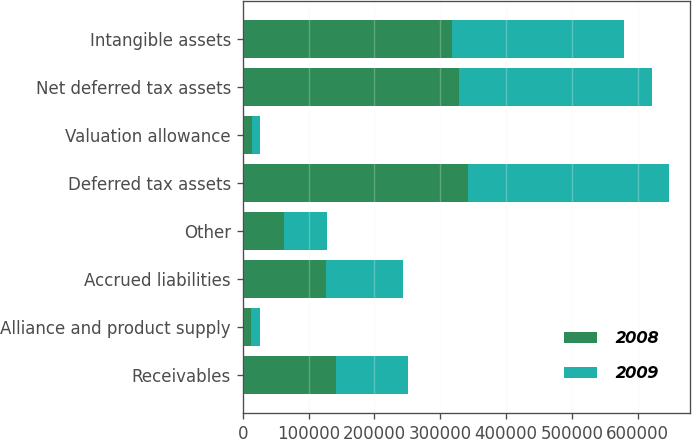<chart> <loc_0><loc_0><loc_500><loc_500><stacked_bar_chart><ecel><fcel>Receivables<fcel>Alliance and product supply<fcel>Accrued liabilities<fcel>Other<fcel>Deferred tax assets<fcel>Valuation allowance<fcel>Net deferred tax assets<fcel>Intangible assets<nl><fcel>2008<fcel>142315<fcel>11922<fcel>125992<fcel>62208<fcel>342437<fcel>14191<fcel>328246<fcel>317306<nl><fcel>2009<fcel>108275<fcel>13995<fcel>117474<fcel>65635<fcel>305379<fcel>12588<fcel>292791<fcel>262029<nl></chart> 